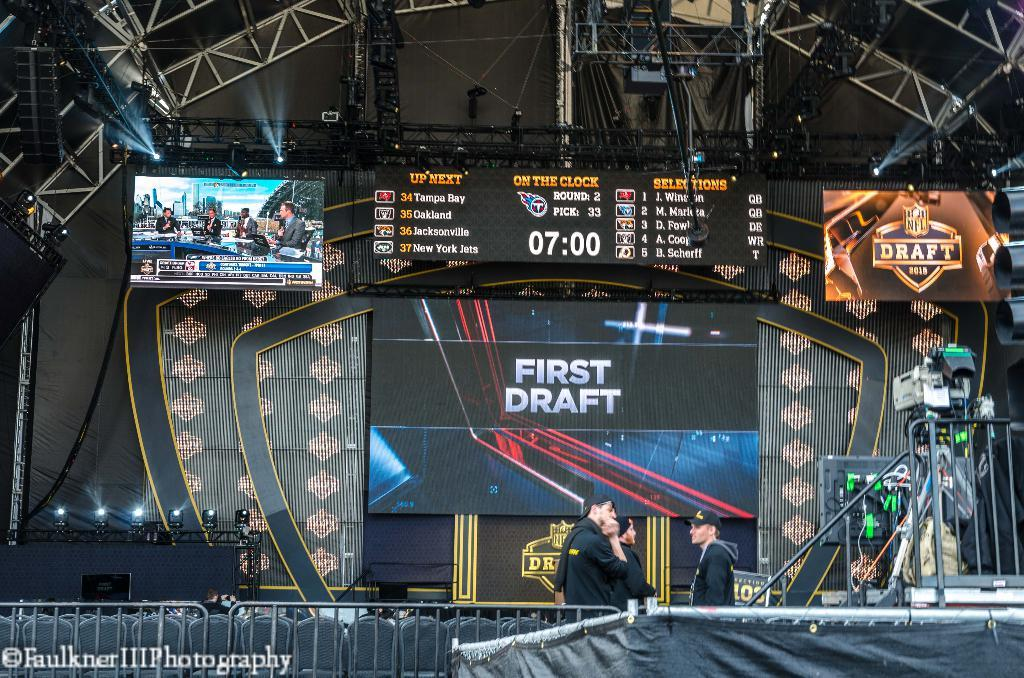<image>
Write a terse but informative summary of the picture. A large indoor stadium with a big screen that says First Draft. 